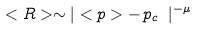Convert formula to latex. <formula><loc_0><loc_0><loc_500><loc_500>< R > \sim | < p > - \, p _ { c } \ | ^ { - \mu }</formula> 